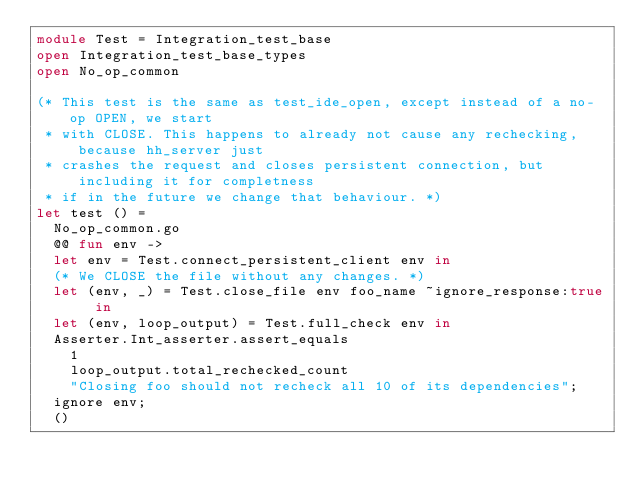<code> <loc_0><loc_0><loc_500><loc_500><_OCaml_>module Test = Integration_test_base
open Integration_test_base_types
open No_op_common

(* This test is the same as test_ide_open, except instead of a no-op OPEN, we start
 * with CLOSE. This happens to already not cause any rechecking, because hh_server just
 * crashes the request and closes persistent connection, but including it for completness
 * if in the future we change that behaviour. *)
let test () =
  No_op_common.go
  @@ fun env ->
  let env = Test.connect_persistent_client env in
  (* We CLOSE the file without any changes. *)
  let (env, _) = Test.close_file env foo_name ~ignore_response:true in
  let (env, loop_output) = Test.full_check env in
  Asserter.Int_asserter.assert_equals
    1
    loop_output.total_rechecked_count
    "Closing foo should not recheck all 10 of its dependencies";
  ignore env;
  ()
</code> 